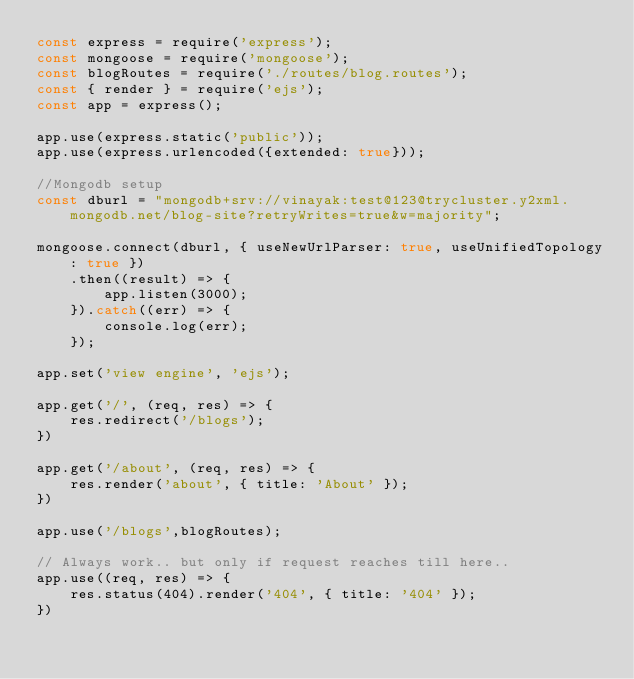<code> <loc_0><loc_0><loc_500><loc_500><_JavaScript_>const express = require('express');
const mongoose = require('mongoose');
const blogRoutes = require('./routes/blog.routes');
const { render } = require('ejs');
const app = express();

app.use(express.static('public'));
app.use(express.urlencoded({extended: true}));

//Mongodb setup
const dburl = "mongodb+srv://vinayak:test@123@trycluster.y2xml.mongodb.net/blog-site?retryWrites=true&w=majority";

mongoose.connect(dburl, { useNewUrlParser: true, useUnifiedTopology: true })
    .then((result) => {
        app.listen(3000);
    }).catch((err) => {
        console.log(err);
    });

app.set('view engine', 'ejs');

app.get('/', (req, res) => {
    res.redirect('/blogs');
})

app.get('/about', (req, res) => {
    res.render('about', { title: 'About' });
})

app.use('/blogs',blogRoutes);

// Always work.. but only if request reaches till here..
app.use((req, res) => {
    res.status(404).render('404', { title: '404' });
})</code> 